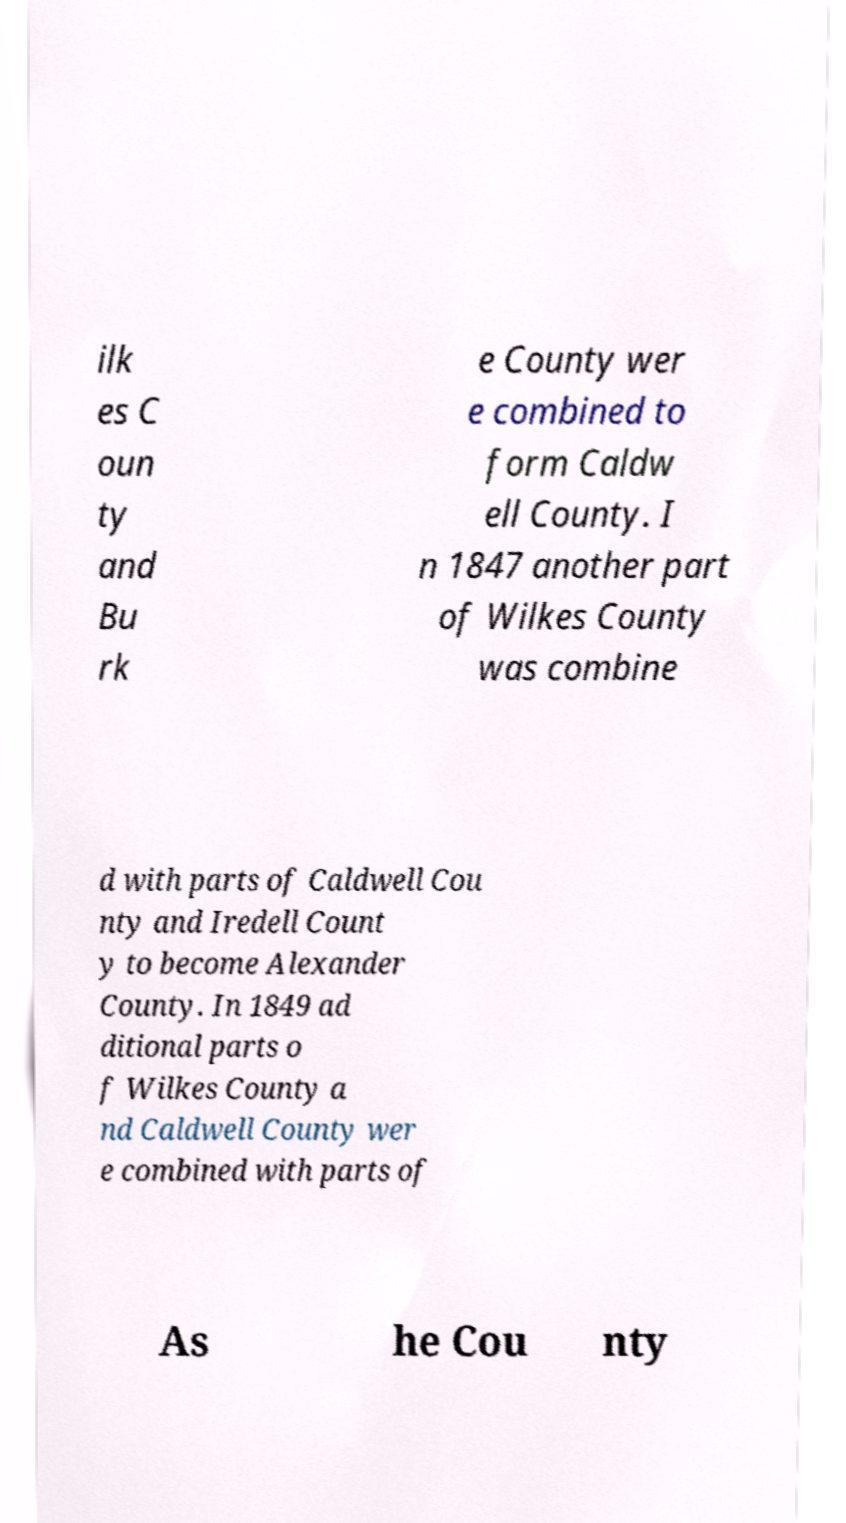Please identify and transcribe the text found in this image. ilk es C oun ty and Bu rk e County wer e combined to form Caldw ell County. I n 1847 another part of Wilkes County was combine d with parts of Caldwell Cou nty and Iredell Count y to become Alexander County. In 1849 ad ditional parts o f Wilkes County a nd Caldwell County wer e combined with parts of As he Cou nty 